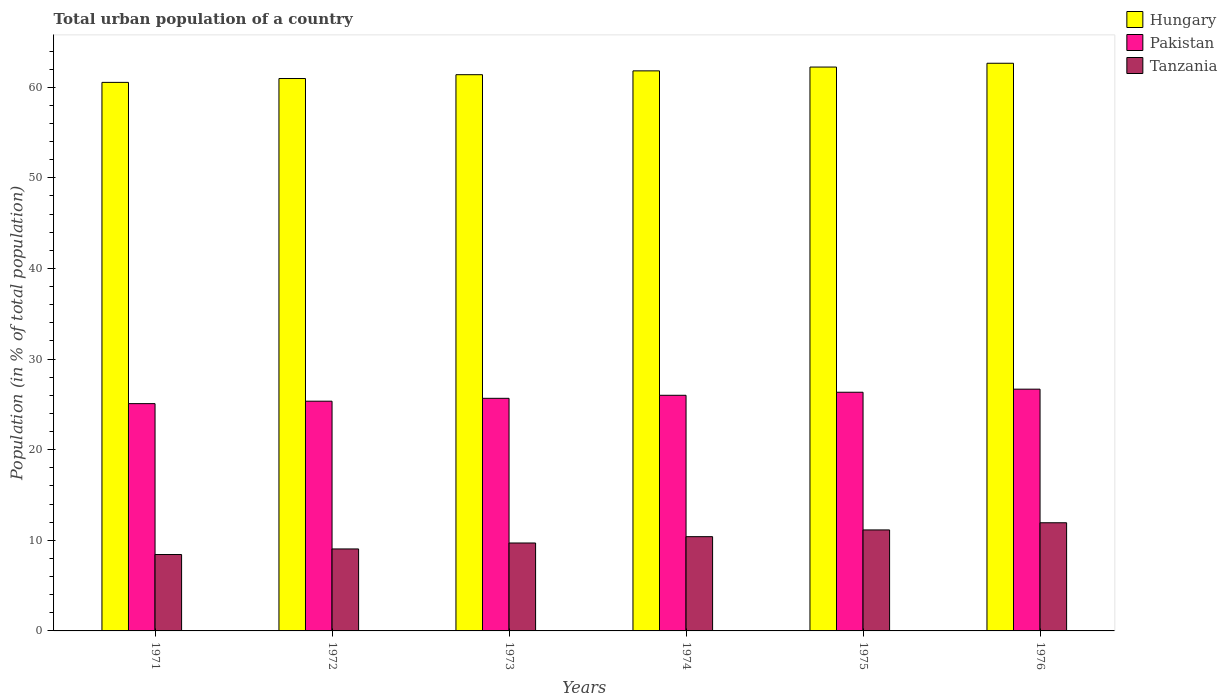How many groups of bars are there?
Ensure brevity in your answer.  6. Are the number of bars per tick equal to the number of legend labels?
Provide a succinct answer. Yes. Are the number of bars on each tick of the X-axis equal?
Provide a succinct answer. Yes. How many bars are there on the 4th tick from the right?
Your response must be concise. 3. What is the label of the 4th group of bars from the left?
Offer a terse response. 1974. In how many cases, is the number of bars for a given year not equal to the number of legend labels?
Offer a terse response. 0. What is the urban population in Hungary in 1974?
Your answer should be compact. 61.81. Across all years, what is the maximum urban population in Tanzania?
Ensure brevity in your answer.  11.94. Across all years, what is the minimum urban population in Pakistan?
Keep it short and to the point. 25.08. In which year was the urban population in Hungary maximum?
Offer a very short reply. 1976. What is the total urban population in Hungary in the graph?
Your answer should be very brief. 369.58. What is the difference between the urban population in Pakistan in 1971 and that in 1976?
Make the answer very short. -1.6. What is the difference between the urban population in Pakistan in 1972 and the urban population in Hungary in 1971?
Provide a succinct answer. -35.19. What is the average urban population in Tanzania per year?
Make the answer very short. 10.11. In the year 1974, what is the difference between the urban population in Tanzania and urban population in Pakistan?
Keep it short and to the point. -15.6. What is the ratio of the urban population in Hungary in 1974 to that in 1975?
Provide a succinct answer. 0.99. Is the urban population in Hungary in 1973 less than that in 1975?
Ensure brevity in your answer.  Yes. What is the difference between the highest and the second highest urban population in Hungary?
Offer a terse response. 0.42. What is the difference between the highest and the lowest urban population in Tanzania?
Ensure brevity in your answer.  3.51. Is the sum of the urban population in Tanzania in 1973 and 1975 greater than the maximum urban population in Pakistan across all years?
Provide a succinct answer. No. What does the 1st bar from the left in 1972 represents?
Offer a terse response. Hungary. What does the 2nd bar from the right in 1975 represents?
Offer a terse response. Pakistan. Is it the case that in every year, the sum of the urban population in Pakistan and urban population in Tanzania is greater than the urban population in Hungary?
Your answer should be compact. No. How many bars are there?
Provide a short and direct response. 18. Does the graph contain any zero values?
Offer a terse response. No. How many legend labels are there?
Provide a succinct answer. 3. How are the legend labels stacked?
Keep it short and to the point. Vertical. What is the title of the graph?
Offer a terse response. Total urban population of a country. What is the label or title of the Y-axis?
Make the answer very short. Population (in % of total population). What is the Population (in % of total population) in Hungary in 1971?
Provide a short and direct response. 60.54. What is the Population (in % of total population) in Pakistan in 1971?
Ensure brevity in your answer.  25.08. What is the Population (in % of total population) in Tanzania in 1971?
Your answer should be compact. 8.43. What is the Population (in % of total population) of Hungary in 1972?
Offer a terse response. 60.97. What is the Population (in % of total population) of Pakistan in 1972?
Provide a short and direct response. 25.35. What is the Population (in % of total population) of Tanzania in 1972?
Provide a short and direct response. 9.05. What is the Population (in % of total population) in Hungary in 1973?
Provide a short and direct response. 61.39. What is the Population (in % of total population) in Pakistan in 1973?
Keep it short and to the point. 25.67. What is the Population (in % of total population) of Tanzania in 1973?
Make the answer very short. 9.7. What is the Population (in % of total population) in Hungary in 1974?
Make the answer very short. 61.81. What is the Population (in % of total population) of Pakistan in 1974?
Provide a short and direct response. 26. What is the Population (in % of total population) of Tanzania in 1974?
Your answer should be very brief. 10.4. What is the Population (in % of total population) in Hungary in 1975?
Give a very brief answer. 62.23. What is the Population (in % of total population) in Pakistan in 1975?
Keep it short and to the point. 26.34. What is the Population (in % of total population) in Tanzania in 1975?
Keep it short and to the point. 11.15. What is the Population (in % of total population) in Hungary in 1976?
Offer a terse response. 62.65. What is the Population (in % of total population) in Pakistan in 1976?
Make the answer very short. 26.68. What is the Population (in % of total population) in Tanzania in 1976?
Offer a terse response. 11.94. Across all years, what is the maximum Population (in % of total population) in Hungary?
Your answer should be compact. 62.65. Across all years, what is the maximum Population (in % of total population) of Pakistan?
Offer a terse response. 26.68. Across all years, what is the maximum Population (in % of total population) in Tanzania?
Provide a short and direct response. 11.94. Across all years, what is the minimum Population (in % of total population) of Hungary?
Offer a terse response. 60.54. Across all years, what is the minimum Population (in % of total population) of Pakistan?
Offer a very short reply. 25.08. Across all years, what is the minimum Population (in % of total population) in Tanzania?
Ensure brevity in your answer.  8.43. What is the total Population (in % of total population) of Hungary in the graph?
Offer a terse response. 369.58. What is the total Population (in % of total population) in Pakistan in the graph?
Make the answer very short. 155.13. What is the total Population (in % of total population) of Tanzania in the graph?
Offer a terse response. 60.67. What is the difference between the Population (in % of total population) in Hungary in 1971 and that in 1972?
Provide a succinct answer. -0.43. What is the difference between the Population (in % of total population) in Pakistan in 1971 and that in 1972?
Offer a very short reply. -0.27. What is the difference between the Population (in % of total population) of Tanzania in 1971 and that in 1972?
Your answer should be compact. -0.62. What is the difference between the Population (in % of total population) of Hungary in 1971 and that in 1973?
Provide a succinct answer. -0.85. What is the difference between the Population (in % of total population) of Pakistan in 1971 and that in 1973?
Your answer should be very brief. -0.59. What is the difference between the Population (in % of total population) of Tanzania in 1971 and that in 1973?
Offer a very short reply. -1.27. What is the difference between the Population (in % of total population) of Hungary in 1971 and that in 1974?
Keep it short and to the point. -1.27. What is the difference between the Population (in % of total population) of Pakistan in 1971 and that in 1974?
Give a very brief answer. -0.92. What is the difference between the Population (in % of total population) in Tanzania in 1971 and that in 1974?
Provide a short and direct response. -1.97. What is the difference between the Population (in % of total population) of Hungary in 1971 and that in 1975?
Make the answer very short. -1.69. What is the difference between the Population (in % of total population) in Pakistan in 1971 and that in 1975?
Keep it short and to the point. -1.26. What is the difference between the Population (in % of total population) in Tanzania in 1971 and that in 1975?
Your answer should be very brief. -2.71. What is the difference between the Population (in % of total population) in Hungary in 1971 and that in 1976?
Your answer should be compact. -2.11. What is the difference between the Population (in % of total population) in Pakistan in 1971 and that in 1976?
Offer a terse response. -1.6. What is the difference between the Population (in % of total population) in Tanzania in 1971 and that in 1976?
Ensure brevity in your answer.  -3.51. What is the difference between the Population (in % of total population) of Hungary in 1972 and that in 1973?
Make the answer very short. -0.42. What is the difference between the Population (in % of total population) of Pakistan in 1972 and that in 1973?
Give a very brief answer. -0.32. What is the difference between the Population (in % of total population) in Tanzania in 1972 and that in 1973?
Make the answer very short. -0.66. What is the difference between the Population (in % of total population) of Hungary in 1972 and that in 1974?
Offer a very short reply. -0.84. What is the difference between the Population (in % of total population) in Pakistan in 1972 and that in 1974?
Your answer should be very brief. -0.65. What is the difference between the Population (in % of total population) in Tanzania in 1972 and that in 1974?
Offer a very short reply. -1.35. What is the difference between the Population (in % of total population) in Hungary in 1972 and that in 1975?
Offer a terse response. -1.27. What is the difference between the Population (in % of total population) in Pakistan in 1972 and that in 1975?
Give a very brief answer. -0.99. What is the difference between the Population (in % of total population) in Tanzania in 1972 and that in 1975?
Provide a succinct answer. -2.1. What is the difference between the Population (in % of total population) of Hungary in 1972 and that in 1976?
Offer a terse response. -1.69. What is the difference between the Population (in % of total population) in Pakistan in 1972 and that in 1976?
Keep it short and to the point. -1.33. What is the difference between the Population (in % of total population) of Tanzania in 1972 and that in 1976?
Your answer should be compact. -2.89. What is the difference between the Population (in % of total population) in Hungary in 1973 and that in 1974?
Your answer should be very brief. -0.42. What is the difference between the Population (in % of total population) in Pakistan in 1973 and that in 1974?
Offer a very short reply. -0.33. What is the difference between the Population (in % of total population) of Tanzania in 1973 and that in 1974?
Offer a terse response. -0.7. What is the difference between the Population (in % of total population) of Hungary in 1973 and that in 1975?
Offer a terse response. -0.84. What is the difference between the Population (in % of total population) in Pakistan in 1973 and that in 1975?
Your answer should be compact. -0.67. What is the difference between the Population (in % of total population) of Tanzania in 1973 and that in 1975?
Offer a very short reply. -1.44. What is the difference between the Population (in % of total population) in Hungary in 1973 and that in 1976?
Keep it short and to the point. -1.26. What is the difference between the Population (in % of total population) of Pakistan in 1973 and that in 1976?
Your response must be concise. -1.01. What is the difference between the Population (in % of total population) of Tanzania in 1973 and that in 1976?
Keep it short and to the point. -2.23. What is the difference between the Population (in % of total population) of Hungary in 1974 and that in 1975?
Keep it short and to the point. -0.42. What is the difference between the Population (in % of total population) in Pakistan in 1974 and that in 1975?
Make the answer very short. -0.34. What is the difference between the Population (in % of total population) of Tanzania in 1974 and that in 1975?
Offer a very short reply. -0.74. What is the difference between the Population (in % of total population) in Hungary in 1974 and that in 1976?
Your response must be concise. -0.84. What is the difference between the Population (in % of total population) in Pakistan in 1974 and that in 1976?
Provide a short and direct response. -0.68. What is the difference between the Population (in % of total population) of Tanzania in 1974 and that in 1976?
Provide a short and direct response. -1.53. What is the difference between the Population (in % of total population) of Hungary in 1975 and that in 1976?
Provide a short and direct response. -0.42. What is the difference between the Population (in % of total population) of Pakistan in 1975 and that in 1976?
Make the answer very short. -0.34. What is the difference between the Population (in % of total population) in Tanzania in 1975 and that in 1976?
Offer a terse response. -0.79. What is the difference between the Population (in % of total population) of Hungary in 1971 and the Population (in % of total population) of Pakistan in 1972?
Keep it short and to the point. 35.19. What is the difference between the Population (in % of total population) in Hungary in 1971 and the Population (in % of total population) in Tanzania in 1972?
Offer a very short reply. 51.49. What is the difference between the Population (in % of total population) of Pakistan in 1971 and the Population (in % of total population) of Tanzania in 1972?
Provide a short and direct response. 16.04. What is the difference between the Population (in % of total population) in Hungary in 1971 and the Population (in % of total population) in Pakistan in 1973?
Give a very brief answer. 34.87. What is the difference between the Population (in % of total population) of Hungary in 1971 and the Population (in % of total population) of Tanzania in 1973?
Ensure brevity in your answer.  50.84. What is the difference between the Population (in % of total population) of Pakistan in 1971 and the Population (in % of total population) of Tanzania in 1973?
Offer a terse response. 15.38. What is the difference between the Population (in % of total population) of Hungary in 1971 and the Population (in % of total population) of Pakistan in 1974?
Offer a very short reply. 34.53. What is the difference between the Population (in % of total population) of Hungary in 1971 and the Population (in % of total population) of Tanzania in 1974?
Keep it short and to the point. 50.14. What is the difference between the Population (in % of total population) in Pakistan in 1971 and the Population (in % of total population) in Tanzania in 1974?
Your response must be concise. 14.68. What is the difference between the Population (in % of total population) in Hungary in 1971 and the Population (in % of total population) in Pakistan in 1975?
Offer a very short reply. 34.2. What is the difference between the Population (in % of total population) of Hungary in 1971 and the Population (in % of total population) of Tanzania in 1975?
Provide a succinct answer. 49.39. What is the difference between the Population (in % of total population) in Pakistan in 1971 and the Population (in % of total population) in Tanzania in 1975?
Your response must be concise. 13.94. What is the difference between the Population (in % of total population) in Hungary in 1971 and the Population (in % of total population) in Pakistan in 1976?
Your response must be concise. 33.86. What is the difference between the Population (in % of total population) of Hungary in 1971 and the Population (in % of total population) of Tanzania in 1976?
Ensure brevity in your answer.  48.6. What is the difference between the Population (in % of total population) in Pakistan in 1971 and the Population (in % of total population) in Tanzania in 1976?
Provide a succinct answer. 13.15. What is the difference between the Population (in % of total population) of Hungary in 1972 and the Population (in % of total population) of Pakistan in 1973?
Your response must be concise. 35.29. What is the difference between the Population (in % of total population) of Hungary in 1972 and the Population (in % of total population) of Tanzania in 1973?
Provide a short and direct response. 51.26. What is the difference between the Population (in % of total population) in Pakistan in 1972 and the Population (in % of total population) in Tanzania in 1973?
Offer a terse response. 15.65. What is the difference between the Population (in % of total population) of Hungary in 1972 and the Population (in % of total population) of Pakistan in 1974?
Your answer should be compact. 34.96. What is the difference between the Population (in % of total population) of Hungary in 1972 and the Population (in % of total population) of Tanzania in 1974?
Ensure brevity in your answer.  50.56. What is the difference between the Population (in % of total population) of Pakistan in 1972 and the Population (in % of total population) of Tanzania in 1974?
Your answer should be compact. 14.95. What is the difference between the Population (in % of total population) of Hungary in 1972 and the Population (in % of total population) of Pakistan in 1975?
Keep it short and to the point. 34.62. What is the difference between the Population (in % of total population) in Hungary in 1972 and the Population (in % of total population) in Tanzania in 1975?
Your answer should be very brief. 49.82. What is the difference between the Population (in % of total population) of Pakistan in 1972 and the Population (in % of total population) of Tanzania in 1975?
Offer a terse response. 14.21. What is the difference between the Population (in % of total population) of Hungary in 1972 and the Population (in % of total population) of Pakistan in 1976?
Your answer should be compact. 34.28. What is the difference between the Population (in % of total population) in Hungary in 1972 and the Population (in % of total population) in Tanzania in 1976?
Your answer should be compact. 49.03. What is the difference between the Population (in % of total population) of Pakistan in 1972 and the Population (in % of total population) of Tanzania in 1976?
Your response must be concise. 13.42. What is the difference between the Population (in % of total population) in Hungary in 1973 and the Population (in % of total population) in Pakistan in 1974?
Your answer should be very brief. 35.38. What is the difference between the Population (in % of total population) in Hungary in 1973 and the Population (in % of total population) in Tanzania in 1974?
Ensure brevity in your answer.  50.98. What is the difference between the Population (in % of total population) of Pakistan in 1973 and the Population (in % of total population) of Tanzania in 1974?
Provide a succinct answer. 15.27. What is the difference between the Population (in % of total population) of Hungary in 1973 and the Population (in % of total population) of Pakistan in 1975?
Offer a very short reply. 35.05. What is the difference between the Population (in % of total population) in Hungary in 1973 and the Population (in % of total population) in Tanzania in 1975?
Your response must be concise. 50.24. What is the difference between the Population (in % of total population) of Pakistan in 1973 and the Population (in % of total population) of Tanzania in 1975?
Offer a terse response. 14.53. What is the difference between the Population (in % of total population) in Hungary in 1973 and the Population (in % of total population) in Pakistan in 1976?
Offer a very short reply. 34.71. What is the difference between the Population (in % of total population) in Hungary in 1973 and the Population (in % of total population) in Tanzania in 1976?
Give a very brief answer. 49.45. What is the difference between the Population (in % of total population) in Pakistan in 1973 and the Population (in % of total population) in Tanzania in 1976?
Your response must be concise. 13.73. What is the difference between the Population (in % of total population) in Hungary in 1974 and the Population (in % of total population) in Pakistan in 1975?
Provide a succinct answer. 35.47. What is the difference between the Population (in % of total population) in Hungary in 1974 and the Population (in % of total population) in Tanzania in 1975?
Provide a short and direct response. 50.66. What is the difference between the Population (in % of total population) in Pakistan in 1974 and the Population (in % of total population) in Tanzania in 1975?
Your response must be concise. 14.86. What is the difference between the Population (in % of total population) in Hungary in 1974 and the Population (in % of total population) in Pakistan in 1976?
Your response must be concise. 35.13. What is the difference between the Population (in % of total population) of Hungary in 1974 and the Population (in % of total population) of Tanzania in 1976?
Provide a succinct answer. 49.87. What is the difference between the Population (in % of total population) of Pakistan in 1974 and the Population (in % of total population) of Tanzania in 1976?
Offer a terse response. 14.07. What is the difference between the Population (in % of total population) of Hungary in 1975 and the Population (in % of total population) of Pakistan in 1976?
Ensure brevity in your answer.  35.55. What is the difference between the Population (in % of total population) of Hungary in 1975 and the Population (in % of total population) of Tanzania in 1976?
Keep it short and to the point. 50.29. What is the difference between the Population (in % of total population) of Pakistan in 1975 and the Population (in % of total population) of Tanzania in 1976?
Keep it short and to the point. 14.4. What is the average Population (in % of total population) in Hungary per year?
Your answer should be compact. 61.6. What is the average Population (in % of total population) in Pakistan per year?
Your answer should be compact. 25.86. What is the average Population (in % of total population) of Tanzania per year?
Give a very brief answer. 10.11. In the year 1971, what is the difference between the Population (in % of total population) in Hungary and Population (in % of total population) in Pakistan?
Keep it short and to the point. 35.45. In the year 1971, what is the difference between the Population (in % of total population) of Hungary and Population (in % of total population) of Tanzania?
Ensure brevity in your answer.  52.11. In the year 1971, what is the difference between the Population (in % of total population) of Pakistan and Population (in % of total population) of Tanzania?
Your answer should be very brief. 16.65. In the year 1972, what is the difference between the Population (in % of total population) of Hungary and Population (in % of total population) of Pakistan?
Offer a very short reply. 35.61. In the year 1972, what is the difference between the Population (in % of total population) in Hungary and Population (in % of total population) in Tanzania?
Make the answer very short. 51.92. In the year 1972, what is the difference between the Population (in % of total population) of Pakistan and Population (in % of total population) of Tanzania?
Your response must be concise. 16.3. In the year 1973, what is the difference between the Population (in % of total population) in Hungary and Population (in % of total population) in Pakistan?
Make the answer very short. 35.72. In the year 1973, what is the difference between the Population (in % of total population) of Hungary and Population (in % of total population) of Tanzania?
Provide a short and direct response. 51.68. In the year 1973, what is the difference between the Population (in % of total population) of Pakistan and Population (in % of total population) of Tanzania?
Provide a succinct answer. 15.97. In the year 1974, what is the difference between the Population (in % of total population) in Hungary and Population (in % of total population) in Pakistan?
Ensure brevity in your answer.  35.8. In the year 1974, what is the difference between the Population (in % of total population) in Hungary and Population (in % of total population) in Tanzania?
Give a very brief answer. 51.41. In the year 1974, what is the difference between the Population (in % of total population) of Pakistan and Population (in % of total population) of Tanzania?
Give a very brief answer. 15.6. In the year 1975, what is the difference between the Population (in % of total population) of Hungary and Population (in % of total population) of Pakistan?
Keep it short and to the point. 35.89. In the year 1975, what is the difference between the Population (in % of total population) of Hungary and Population (in % of total population) of Tanzania?
Your answer should be compact. 51.09. In the year 1975, what is the difference between the Population (in % of total population) in Pakistan and Population (in % of total population) in Tanzania?
Offer a terse response. 15.2. In the year 1976, what is the difference between the Population (in % of total population) of Hungary and Population (in % of total population) of Pakistan?
Your answer should be compact. 35.97. In the year 1976, what is the difference between the Population (in % of total population) in Hungary and Population (in % of total population) in Tanzania?
Offer a terse response. 50.71. In the year 1976, what is the difference between the Population (in % of total population) of Pakistan and Population (in % of total population) of Tanzania?
Keep it short and to the point. 14.74. What is the ratio of the Population (in % of total population) in Tanzania in 1971 to that in 1972?
Make the answer very short. 0.93. What is the ratio of the Population (in % of total population) of Hungary in 1971 to that in 1973?
Give a very brief answer. 0.99. What is the ratio of the Population (in % of total population) of Pakistan in 1971 to that in 1973?
Your answer should be compact. 0.98. What is the ratio of the Population (in % of total population) of Tanzania in 1971 to that in 1973?
Offer a very short reply. 0.87. What is the ratio of the Population (in % of total population) of Hungary in 1971 to that in 1974?
Provide a short and direct response. 0.98. What is the ratio of the Population (in % of total population) in Pakistan in 1971 to that in 1974?
Provide a short and direct response. 0.96. What is the ratio of the Population (in % of total population) in Tanzania in 1971 to that in 1974?
Your answer should be very brief. 0.81. What is the ratio of the Population (in % of total population) of Hungary in 1971 to that in 1975?
Ensure brevity in your answer.  0.97. What is the ratio of the Population (in % of total population) of Pakistan in 1971 to that in 1975?
Make the answer very short. 0.95. What is the ratio of the Population (in % of total population) of Tanzania in 1971 to that in 1975?
Make the answer very short. 0.76. What is the ratio of the Population (in % of total population) of Hungary in 1971 to that in 1976?
Make the answer very short. 0.97. What is the ratio of the Population (in % of total population) of Pakistan in 1971 to that in 1976?
Offer a very short reply. 0.94. What is the ratio of the Population (in % of total population) of Tanzania in 1971 to that in 1976?
Offer a very short reply. 0.71. What is the ratio of the Population (in % of total population) in Hungary in 1972 to that in 1973?
Your answer should be compact. 0.99. What is the ratio of the Population (in % of total population) in Pakistan in 1972 to that in 1973?
Give a very brief answer. 0.99. What is the ratio of the Population (in % of total population) in Tanzania in 1972 to that in 1973?
Keep it short and to the point. 0.93. What is the ratio of the Population (in % of total population) in Hungary in 1972 to that in 1974?
Ensure brevity in your answer.  0.99. What is the ratio of the Population (in % of total population) of Pakistan in 1972 to that in 1974?
Provide a short and direct response. 0.97. What is the ratio of the Population (in % of total population) of Tanzania in 1972 to that in 1974?
Provide a succinct answer. 0.87. What is the ratio of the Population (in % of total population) of Hungary in 1972 to that in 1975?
Ensure brevity in your answer.  0.98. What is the ratio of the Population (in % of total population) in Pakistan in 1972 to that in 1975?
Your answer should be very brief. 0.96. What is the ratio of the Population (in % of total population) of Tanzania in 1972 to that in 1975?
Offer a very short reply. 0.81. What is the ratio of the Population (in % of total population) in Hungary in 1972 to that in 1976?
Provide a succinct answer. 0.97. What is the ratio of the Population (in % of total population) of Pakistan in 1972 to that in 1976?
Offer a very short reply. 0.95. What is the ratio of the Population (in % of total population) of Tanzania in 1972 to that in 1976?
Make the answer very short. 0.76. What is the ratio of the Population (in % of total population) in Hungary in 1973 to that in 1974?
Keep it short and to the point. 0.99. What is the ratio of the Population (in % of total population) of Pakistan in 1973 to that in 1974?
Give a very brief answer. 0.99. What is the ratio of the Population (in % of total population) in Tanzania in 1973 to that in 1974?
Ensure brevity in your answer.  0.93. What is the ratio of the Population (in % of total population) in Hungary in 1973 to that in 1975?
Your response must be concise. 0.99. What is the ratio of the Population (in % of total population) of Pakistan in 1973 to that in 1975?
Give a very brief answer. 0.97. What is the ratio of the Population (in % of total population) in Tanzania in 1973 to that in 1975?
Give a very brief answer. 0.87. What is the ratio of the Population (in % of total population) in Hungary in 1973 to that in 1976?
Provide a short and direct response. 0.98. What is the ratio of the Population (in % of total population) in Pakistan in 1973 to that in 1976?
Offer a very short reply. 0.96. What is the ratio of the Population (in % of total population) of Tanzania in 1973 to that in 1976?
Your answer should be compact. 0.81. What is the ratio of the Population (in % of total population) in Hungary in 1974 to that in 1975?
Offer a very short reply. 0.99. What is the ratio of the Population (in % of total population) of Pakistan in 1974 to that in 1975?
Offer a very short reply. 0.99. What is the ratio of the Population (in % of total population) in Hungary in 1974 to that in 1976?
Offer a very short reply. 0.99. What is the ratio of the Population (in % of total population) of Pakistan in 1974 to that in 1976?
Make the answer very short. 0.97. What is the ratio of the Population (in % of total population) of Tanzania in 1974 to that in 1976?
Make the answer very short. 0.87. What is the ratio of the Population (in % of total population) of Pakistan in 1975 to that in 1976?
Offer a very short reply. 0.99. What is the ratio of the Population (in % of total population) of Tanzania in 1975 to that in 1976?
Your answer should be very brief. 0.93. What is the difference between the highest and the second highest Population (in % of total population) of Hungary?
Your response must be concise. 0.42. What is the difference between the highest and the second highest Population (in % of total population) of Pakistan?
Your response must be concise. 0.34. What is the difference between the highest and the second highest Population (in % of total population) in Tanzania?
Offer a terse response. 0.79. What is the difference between the highest and the lowest Population (in % of total population) in Hungary?
Offer a very short reply. 2.11. What is the difference between the highest and the lowest Population (in % of total population) of Pakistan?
Make the answer very short. 1.6. What is the difference between the highest and the lowest Population (in % of total population) of Tanzania?
Your answer should be very brief. 3.51. 